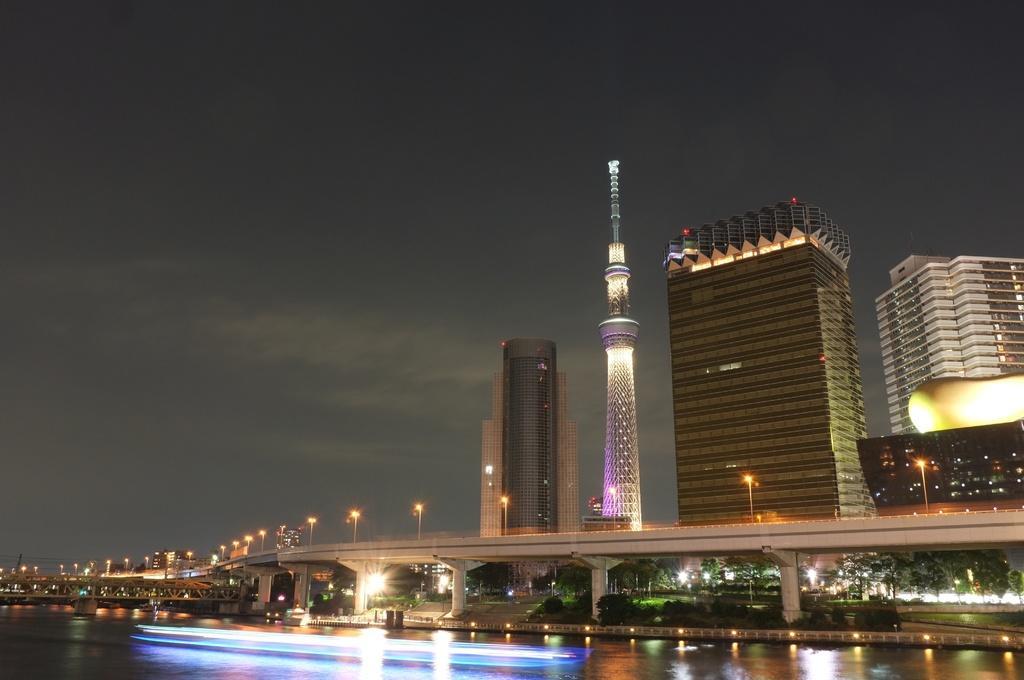How would you summarize this image in a sentence or two? In this image we can see a flyover, behind the flyover one tower and buildings are present. In front of the flyover water pond is there. 